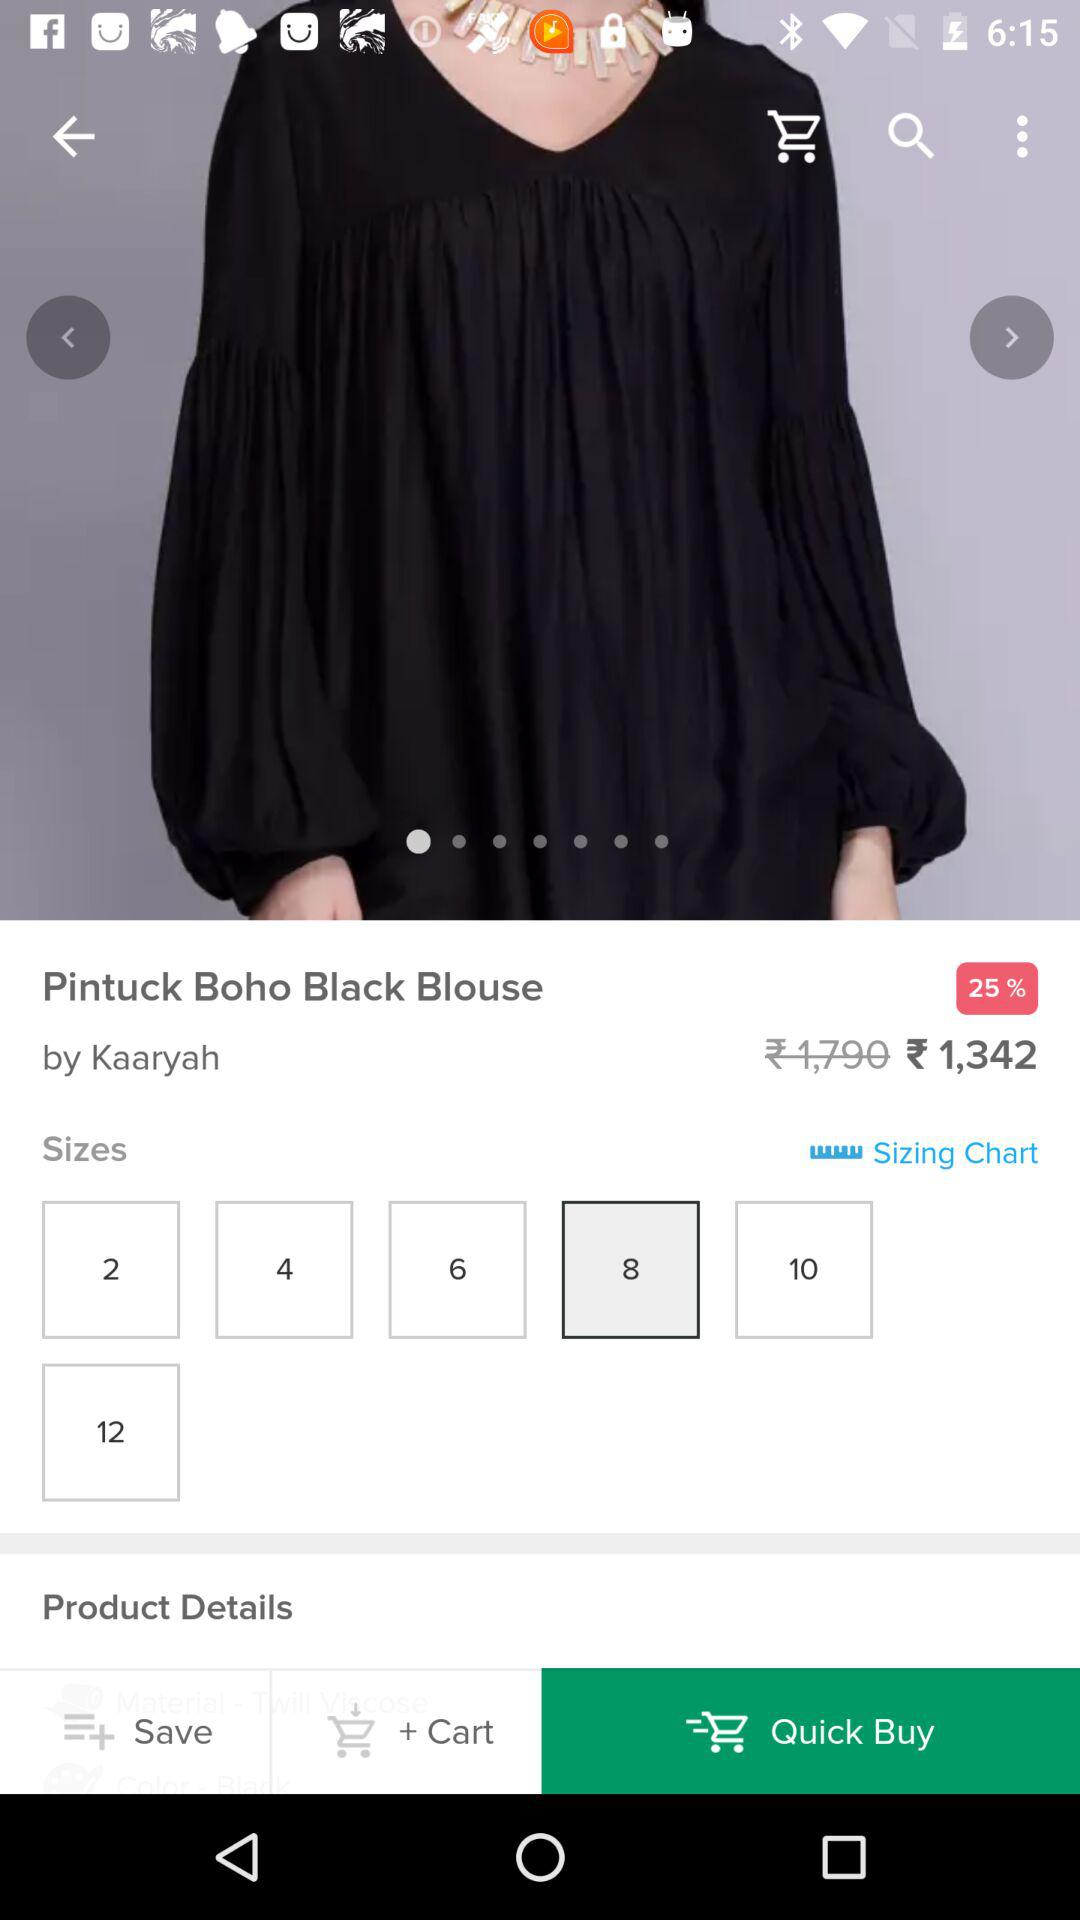How much of a discount is there on the product? There is a 25% discount on the product. 